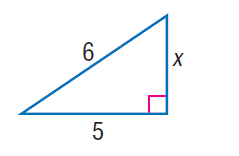Answer the mathemtical geometry problem and directly provide the correct option letter.
Question: Find x.
Choices: A: \sqrt { 7 } B: \sqrt { 10 } C: \sqrt { 11 } D: \sqrt { 13 } C 